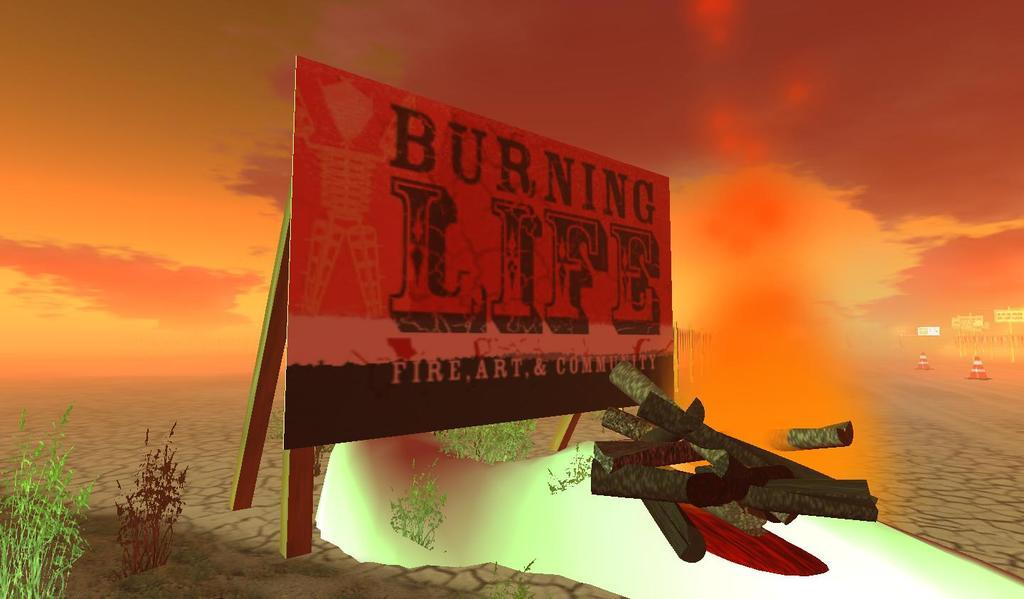Provide a one-sentence caption for the provided image. The sign in the desert says Burning Life. 